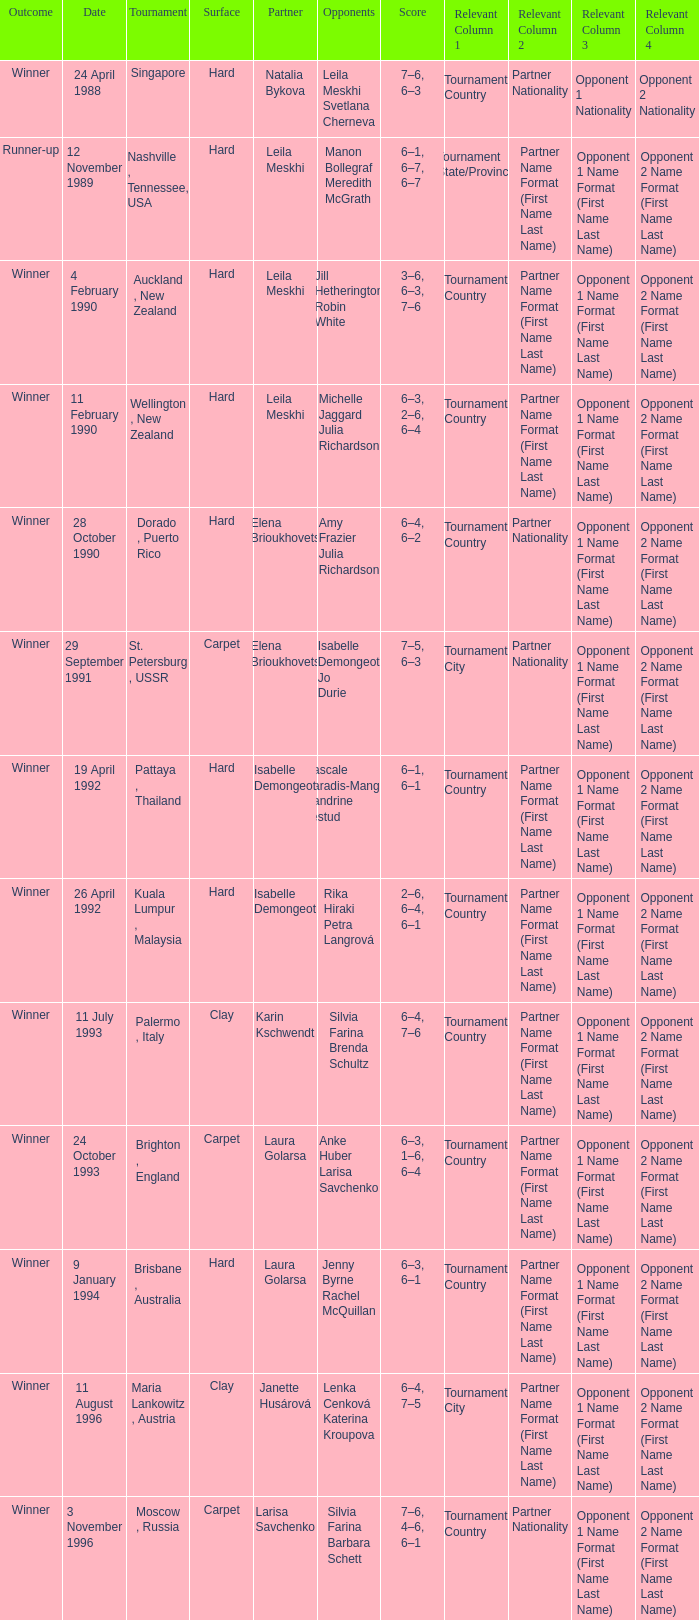In what Tournament was the Score of 3–6, 6–3, 7–6 in a match played on a hard Surface? Auckland , New Zealand. 